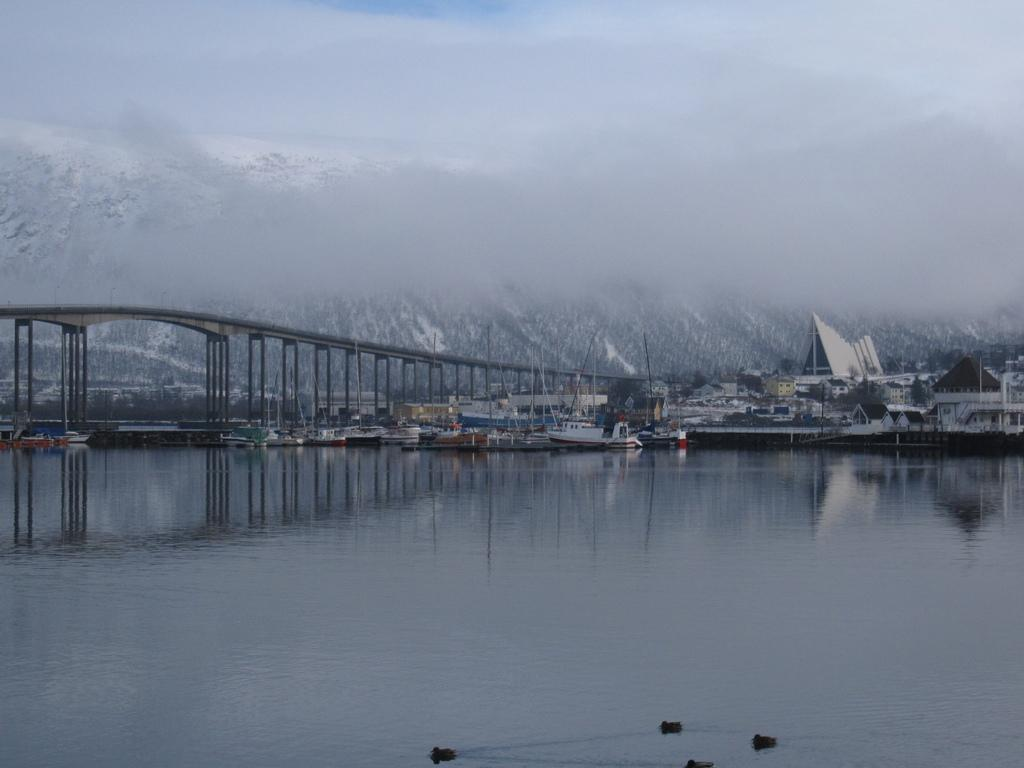What is the primary element visible in the image? There is water in the image. What structures can be seen in the background of the image? There is a bridge, houses, and mountains in the background of the image. What is located under the bridge in the image? There are boats under the bridge in the image. What part of the natural environment is visible in the image? The sky is visible in the background of the image. How many pies are being baked on the boats in the image? There are no pies or baking activities visible in the image; it features boats under a bridge. Can you describe the lizards crawling on the mountains in the image? There are no lizards present in the image; it features mountains in the background. 